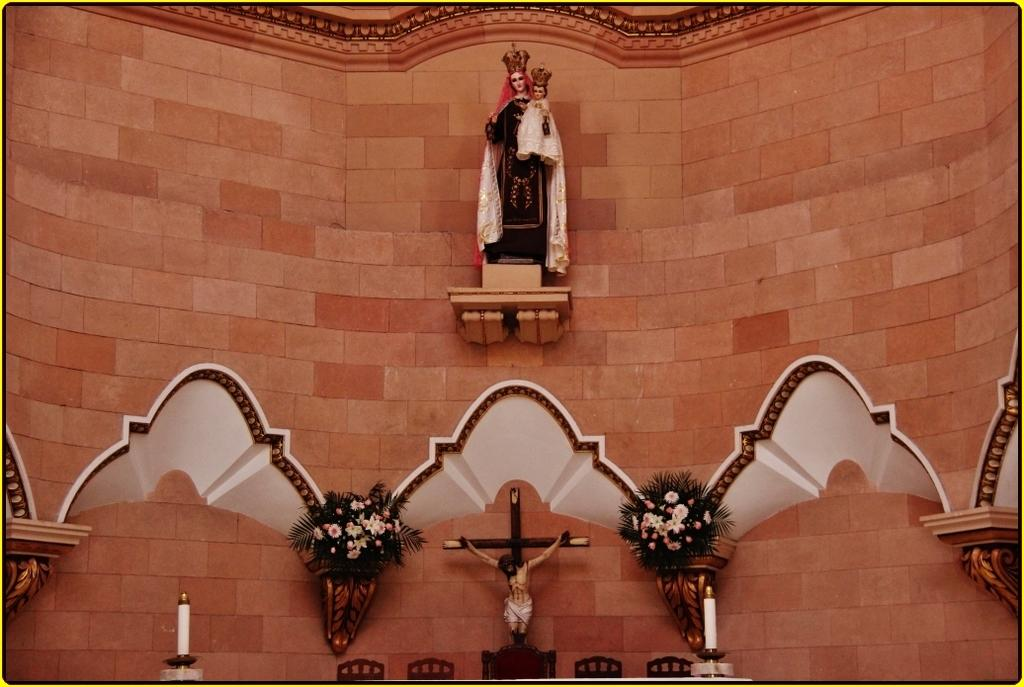What type of location might the image be taken in? The image might be taken in a church. What can be seen at the bottom of the image? There are bouquets, a cross, candles, chairs, a sculpture, and other objects at the bottom of the image. Can you describe the sculpture at the top of the image? There is a sculpture at the top of the image, but no specific details are provided about its appearance. What is the wall at the top of the image made of? The facts do not specify the material of the wall at the top of the image. How does the government act in response to the grip of the sculpture at the top of the image? There is no mention of a government or a grip in the image, so this question cannot be answered based on the provided facts. 